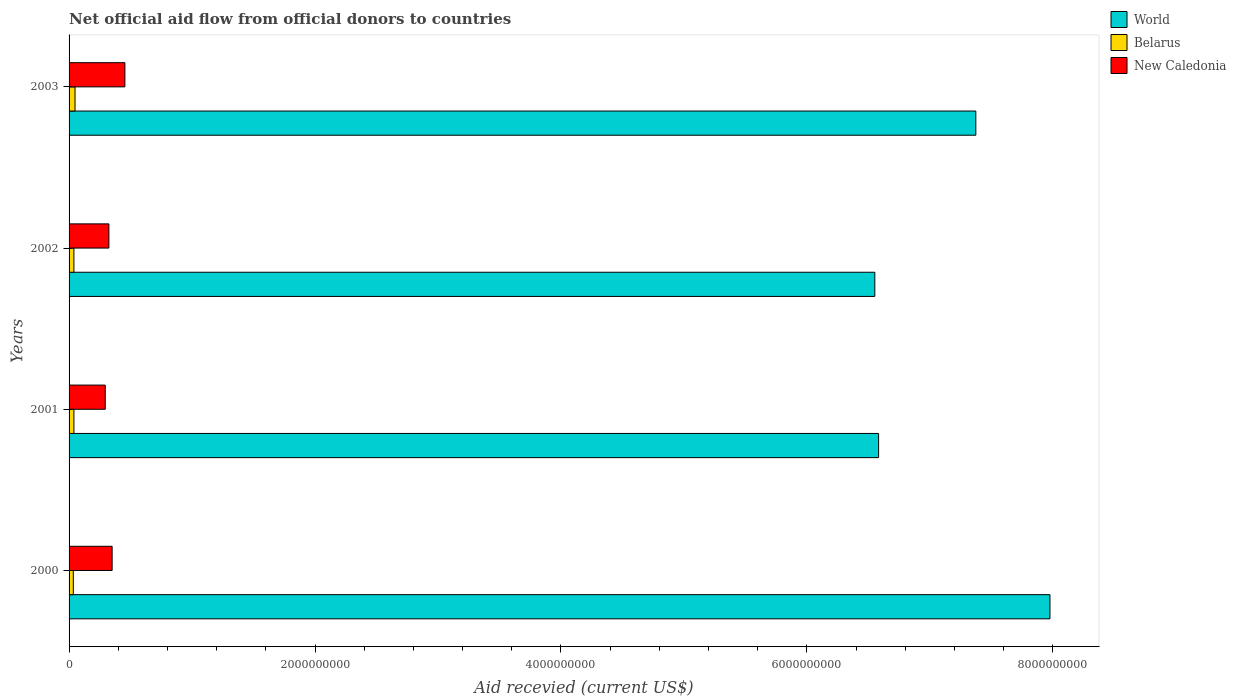How many different coloured bars are there?
Ensure brevity in your answer.  3. How many groups of bars are there?
Provide a succinct answer. 4. Are the number of bars per tick equal to the number of legend labels?
Give a very brief answer. Yes. Are the number of bars on each tick of the Y-axis equal?
Ensure brevity in your answer.  Yes. How many bars are there on the 2nd tick from the top?
Your response must be concise. 3. In how many cases, is the number of bars for a given year not equal to the number of legend labels?
Your response must be concise. 0. What is the total aid received in New Caledonia in 2003?
Give a very brief answer. 4.54e+08. Across all years, what is the maximum total aid received in World?
Your answer should be very brief. 7.98e+09. Across all years, what is the minimum total aid received in World?
Keep it short and to the point. 6.55e+09. What is the total total aid received in New Caledonia in the graph?
Provide a succinct answer. 1.42e+09. What is the difference between the total aid received in Belarus in 2002 and that in 2003?
Ensure brevity in your answer.  -9.15e+06. What is the difference between the total aid received in World in 2003 and the total aid received in New Caledonia in 2002?
Provide a succinct answer. 7.05e+09. What is the average total aid received in New Caledonia per year?
Ensure brevity in your answer.  3.56e+08. In the year 2003, what is the difference between the total aid received in World and total aid received in New Caledonia?
Your response must be concise. 6.92e+09. In how many years, is the total aid received in World greater than 6000000000 US$?
Your response must be concise. 4. What is the ratio of the total aid received in Belarus in 2001 to that in 2003?
Offer a terse response. 0.81. Is the difference between the total aid received in World in 2001 and 2002 greater than the difference between the total aid received in New Caledonia in 2001 and 2002?
Provide a succinct answer. Yes. What is the difference between the highest and the second highest total aid received in New Caledonia?
Give a very brief answer. 1.04e+08. What is the difference between the highest and the lowest total aid received in World?
Your answer should be compact. 1.42e+09. Is the sum of the total aid received in World in 2000 and 2003 greater than the maximum total aid received in New Caledonia across all years?
Provide a succinct answer. Yes. What does the 1st bar from the top in 2002 represents?
Offer a terse response. New Caledonia. What does the 2nd bar from the bottom in 2002 represents?
Offer a terse response. Belarus. Is it the case that in every year, the sum of the total aid received in World and total aid received in New Caledonia is greater than the total aid received in Belarus?
Offer a terse response. Yes. Does the graph contain grids?
Give a very brief answer. No. Where does the legend appear in the graph?
Your response must be concise. Top right. How many legend labels are there?
Keep it short and to the point. 3. What is the title of the graph?
Make the answer very short. Net official aid flow from official donors to countries. What is the label or title of the X-axis?
Offer a very short reply. Aid recevied (current US$). What is the label or title of the Y-axis?
Your answer should be very brief. Years. What is the Aid recevied (current US$) in World in 2000?
Offer a very short reply. 7.98e+09. What is the Aid recevied (current US$) in Belarus in 2000?
Keep it short and to the point. 3.45e+07. What is the Aid recevied (current US$) in New Caledonia in 2000?
Your answer should be very brief. 3.50e+08. What is the Aid recevied (current US$) in World in 2001?
Make the answer very short. 6.58e+09. What is the Aid recevied (current US$) of Belarus in 2001?
Your answer should be compact. 3.94e+07. What is the Aid recevied (current US$) of New Caledonia in 2001?
Ensure brevity in your answer.  2.94e+08. What is the Aid recevied (current US$) in World in 2002?
Provide a short and direct response. 6.55e+09. What is the Aid recevied (current US$) in Belarus in 2002?
Provide a succinct answer. 3.93e+07. What is the Aid recevied (current US$) of New Caledonia in 2002?
Your answer should be compact. 3.24e+08. What is the Aid recevied (current US$) in World in 2003?
Keep it short and to the point. 7.37e+09. What is the Aid recevied (current US$) of Belarus in 2003?
Provide a short and direct response. 4.84e+07. What is the Aid recevied (current US$) in New Caledonia in 2003?
Provide a succinct answer. 4.54e+08. Across all years, what is the maximum Aid recevied (current US$) of World?
Offer a terse response. 7.98e+09. Across all years, what is the maximum Aid recevied (current US$) in Belarus?
Keep it short and to the point. 4.84e+07. Across all years, what is the maximum Aid recevied (current US$) in New Caledonia?
Offer a terse response. 4.54e+08. Across all years, what is the minimum Aid recevied (current US$) of World?
Give a very brief answer. 6.55e+09. Across all years, what is the minimum Aid recevied (current US$) in Belarus?
Your answer should be compact. 3.45e+07. Across all years, what is the minimum Aid recevied (current US$) in New Caledonia?
Make the answer very short. 2.94e+08. What is the total Aid recevied (current US$) in World in the graph?
Your response must be concise. 2.85e+1. What is the total Aid recevied (current US$) in Belarus in the graph?
Provide a short and direct response. 1.62e+08. What is the total Aid recevied (current US$) in New Caledonia in the graph?
Your answer should be compact. 1.42e+09. What is the difference between the Aid recevied (current US$) in World in 2000 and that in 2001?
Provide a short and direct response. 1.39e+09. What is the difference between the Aid recevied (current US$) of Belarus in 2000 and that in 2001?
Your answer should be very brief. -4.96e+06. What is the difference between the Aid recevied (current US$) of New Caledonia in 2000 and that in 2001?
Keep it short and to the point. 5.60e+07. What is the difference between the Aid recevied (current US$) in World in 2000 and that in 2002?
Give a very brief answer. 1.42e+09. What is the difference between the Aid recevied (current US$) in Belarus in 2000 and that in 2002?
Make the answer very short. -4.79e+06. What is the difference between the Aid recevied (current US$) in New Caledonia in 2000 and that in 2002?
Provide a short and direct response. 2.63e+07. What is the difference between the Aid recevied (current US$) in World in 2000 and that in 2003?
Give a very brief answer. 6.03e+08. What is the difference between the Aid recevied (current US$) of Belarus in 2000 and that in 2003?
Provide a succinct answer. -1.39e+07. What is the difference between the Aid recevied (current US$) in New Caledonia in 2000 and that in 2003?
Make the answer very short. -1.04e+08. What is the difference between the Aid recevied (current US$) of World in 2001 and that in 2002?
Keep it short and to the point. 3.09e+07. What is the difference between the Aid recevied (current US$) of New Caledonia in 2001 and that in 2002?
Provide a succinct answer. -2.97e+07. What is the difference between the Aid recevied (current US$) in World in 2001 and that in 2003?
Provide a succinct answer. -7.91e+08. What is the difference between the Aid recevied (current US$) of Belarus in 2001 and that in 2003?
Your answer should be compact. -8.98e+06. What is the difference between the Aid recevied (current US$) in New Caledonia in 2001 and that in 2003?
Keep it short and to the point. -1.60e+08. What is the difference between the Aid recevied (current US$) of World in 2002 and that in 2003?
Provide a succinct answer. -8.22e+08. What is the difference between the Aid recevied (current US$) in Belarus in 2002 and that in 2003?
Your answer should be compact. -9.15e+06. What is the difference between the Aid recevied (current US$) in New Caledonia in 2002 and that in 2003?
Give a very brief answer. -1.30e+08. What is the difference between the Aid recevied (current US$) in World in 2000 and the Aid recevied (current US$) in Belarus in 2001?
Give a very brief answer. 7.94e+09. What is the difference between the Aid recevied (current US$) of World in 2000 and the Aid recevied (current US$) of New Caledonia in 2001?
Give a very brief answer. 7.68e+09. What is the difference between the Aid recevied (current US$) in Belarus in 2000 and the Aid recevied (current US$) in New Caledonia in 2001?
Provide a short and direct response. -2.60e+08. What is the difference between the Aid recevied (current US$) in World in 2000 and the Aid recevied (current US$) in Belarus in 2002?
Ensure brevity in your answer.  7.94e+09. What is the difference between the Aid recevied (current US$) of World in 2000 and the Aid recevied (current US$) of New Caledonia in 2002?
Make the answer very short. 7.65e+09. What is the difference between the Aid recevied (current US$) of Belarus in 2000 and the Aid recevied (current US$) of New Caledonia in 2002?
Ensure brevity in your answer.  -2.89e+08. What is the difference between the Aid recevied (current US$) of World in 2000 and the Aid recevied (current US$) of Belarus in 2003?
Offer a very short reply. 7.93e+09. What is the difference between the Aid recevied (current US$) in World in 2000 and the Aid recevied (current US$) in New Caledonia in 2003?
Offer a terse response. 7.52e+09. What is the difference between the Aid recevied (current US$) in Belarus in 2000 and the Aid recevied (current US$) in New Caledonia in 2003?
Offer a terse response. -4.19e+08. What is the difference between the Aid recevied (current US$) of World in 2001 and the Aid recevied (current US$) of Belarus in 2002?
Offer a terse response. 6.54e+09. What is the difference between the Aid recevied (current US$) in World in 2001 and the Aid recevied (current US$) in New Caledonia in 2002?
Provide a succinct answer. 6.26e+09. What is the difference between the Aid recevied (current US$) in Belarus in 2001 and the Aid recevied (current US$) in New Caledonia in 2002?
Keep it short and to the point. -2.84e+08. What is the difference between the Aid recevied (current US$) of World in 2001 and the Aid recevied (current US$) of Belarus in 2003?
Your answer should be very brief. 6.54e+09. What is the difference between the Aid recevied (current US$) of World in 2001 and the Aid recevied (current US$) of New Caledonia in 2003?
Your answer should be compact. 6.13e+09. What is the difference between the Aid recevied (current US$) of Belarus in 2001 and the Aid recevied (current US$) of New Caledonia in 2003?
Your answer should be very brief. -4.14e+08. What is the difference between the Aid recevied (current US$) in World in 2002 and the Aid recevied (current US$) in Belarus in 2003?
Your answer should be very brief. 6.50e+09. What is the difference between the Aid recevied (current US$) of World in 2002 and the Aid recevied (current US$) of New Caledonia in 2003?
Offer a very short reply. 6.10e+09. What is the difference between the Aid recevied (current US$) of Belarus in 2002 and the Aid recevied (current US$) of New Caledonia in 2003?
Offer a very short reply. -4.15e+08. What is the average Aid recevied (current US$) in World per year?
Offer a very short reply. 7.12e+09. What is the average Aid recevied (current US$) of Belarus per year?
Provide a succinct answer. 4.04e+07. What is the average Aid recevied (current US$) in New Caledonia per year?
Offer a very short reply. 3.56e+08. In the year 2000, what is the difference between the Aid recevied (current US$) of World and Aid recevied (current US$) of Belarus?
Provide a short and direct response. 7.94e+09. In the year 2000, what is the difference between the Aid recevied (current US$) in World and Aid recevied (current US$) in New Caledonia?
Offer a terse response. 7.63e+09. In the year 2000, what is the difference between the Aid recevied (current US$) of Belarus and Aid recevied (current US$) of New Caledonia?
Your answer should be compact. -3.16e+08. In the year 2001, what is the difference between the Aid recevied (current US$) in World and Aid recevied (current US$) in Belarus?
Provide a short and direct response. 6.54e+09. In the year 2001, what is the difference between the Aid recevied (current US$) in World and Aid recevied (current US$) in New Caledonia?
Offer a very short reply. 6.29e+09. In the year 2001, what is the difference between the Aid recevied (current US$) in Belarus and Aid recevied (current US$) in New Caledonia?
Provide a succinct answer. -2.55e+08. In the year 2002, what is the difference between the Aid recevied (current US$) of World and Aid recevied (current US$) of Belarus?
Offer a terse response. 6.51e+09. In the year 2002, what is the difference between the Aid recevied (current US$) of World and Aid recevied (current US$) of New Caledonia?
Provide a short and direct response. 6.23e+09. In the year 2002, what is the difference between the Aid recevied (current US$) of Belarus and Aid recevied (current US$) of New Caledonia?
Offer a very short reply. -2.85e+08. In the year 2003, what is the difference between the Aid recevied (current US$) in World and Aid recevied (current US$) in Belarus?
Keep it short and to the point. 7.33e+09. In the year 2003, what is the difference between the Aid recevied (current US$) of World and Aid recevied (current US$) of New Caledonia?
Provide a short and direct response. 6.92e+09. In the year 2003, what is the difference between the Aid recevied (current US$) of Belarus and Aid recevied (current US$) of New Caledonia?
Offer a terse response. -4.05e+08. What is the ratio of the Aid recevied (current US$) in World in 2000 to that in 2001?
Ensure brevity in your answer.  1.21. What is the ratio of the Aid recevied (current US$) in Belarus in 2000 to that in 2001?
Offer a very short reply. 0.87. What is the ratio of the Aid recevied (current US$) in New Caledonia in 2000 to that in 2001?
Keep it short and to the point. 1.19. What is the ratio of the Aid recevied (current US$) in World in 2000 to that in 2002?
Ensure brevity in your answer.  1.22. What is the ratio of the Aid recevied (current US$) of Belarus in 2000 to that in 2002?
Offer a very short reply. 0.88. What is the ratio of the Aid recevied (current US$) of New Caledonia in 2000 to that in 2002?
Provide a succinct answer. 1.08. What is the ratio of the Aid recevied (current US$) in World in 2000 to that in 2003?
Offer a terse response. 1.08. What is the ratio of the Aid recevied (current US$) in Belarus in 2000 to that in 2003?
Make the answer very short. 0.71. What is the ratio of the Aid recevied (current US$) in New Caledonia in 2000 to that in 2003?
Keep it short and to the point. 0.77. What is the ratio of the Aid recevied (current US$) of New Caledonia in 2001 to that in 2002?
Make the answer very short. 0.91. What is the ratio of the Aid recevied (current US$) in World in 2001 to that in 2003?
Provide a succinct answer. 0.89. What is the ratio of the Aid recevied (current US$) in Belarus in 2001 to that in 2003?
Make the answer very short. 0.81. What is the ratio of the Aid recevied (current US$) in New Caledonia in 2001 to that in 2003?
Your answer should be very brief. 0.65. What is the ratio of the Aid recevied (current US$) of World in 2002 to that in 2003?
Offer a terse response. 0.89. What is the ratio of the Aid recevied (current US$) of Belarus in 2002 to that in 2003?
Provide a short and direct response. 0.81. What is the ratio of the Aid recevied (current US$) in New Caledonia in 2002 to that in 2003?
Offer a very short reply. 0.71. What is the difference between the highest and the second highest Aid recevied (current US$) of World?
Give a very brief answer. 6.03e+08. What is the difference between the highest and the second highest Aid recevied (current US$) of Belarus?
Your answer should be compact. 8.98e+06. What is the difference between the highest and the second highest Aid recevied (current US$) of New Caledonia?
Ensure brevity in your answer.  1.04e+08. What is the difference between the highest and the lowest Aid recevied (current US$) of World?
Give a very brief answer. 1.42e+09. What is the difference between the highest and the lowest Aid recevied (current US$) in Belarus?
Make the answer very short. 1.39e+07. What is the difference between the highest and the lowest Aid recevied (current US$) of New Caledonia?
Give a very brief answer. 1.60e+08. 